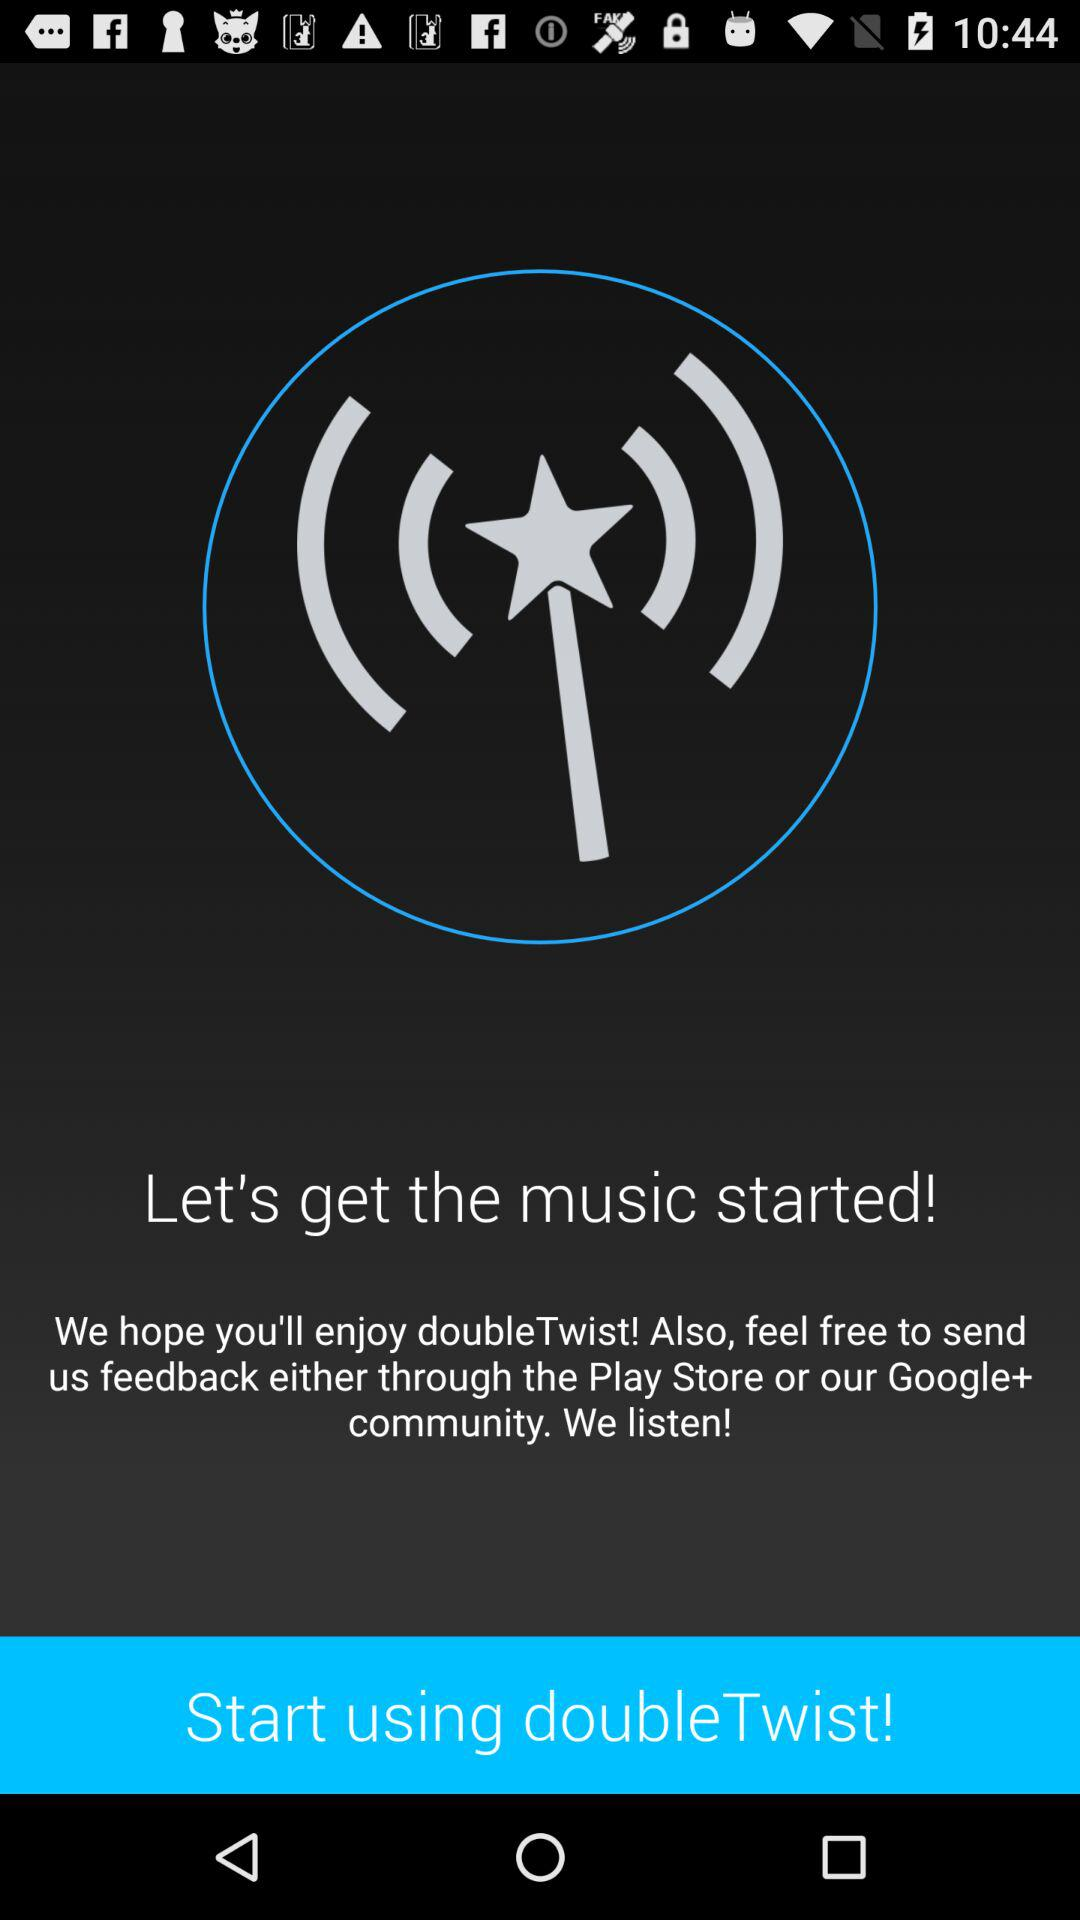Through what application can I send the feedback? You can send feedback through the "Play Store" and the "Google+ community". 